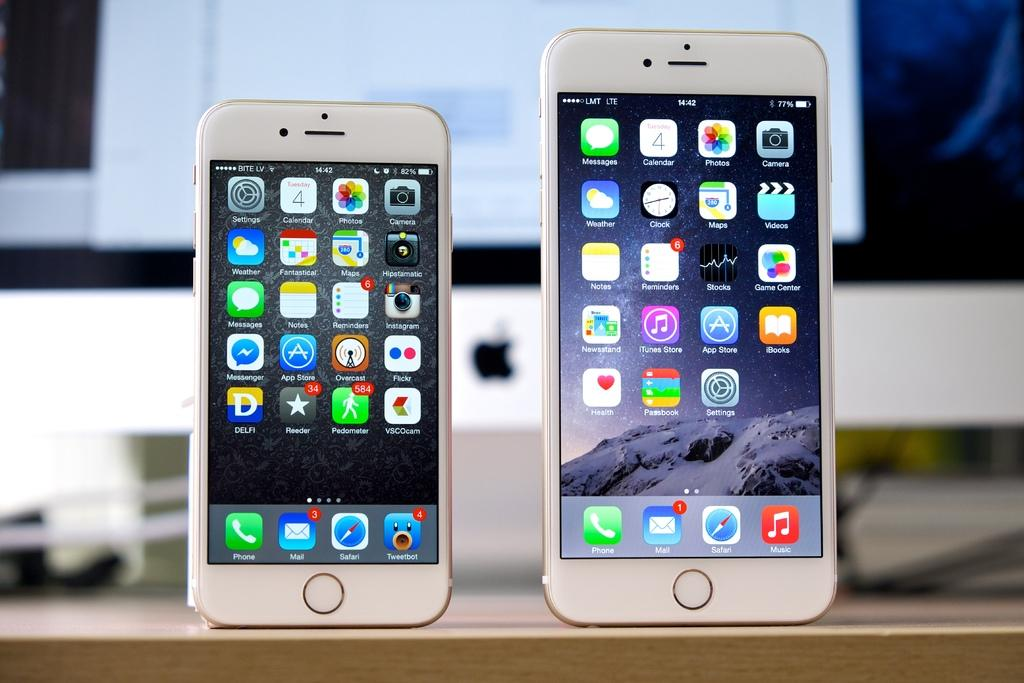What electronic devices are on the table in the image? There are cell phones on the table in the image. What can be seen on the cell phone screens? There are icons and text on the cell phone screens. What is located at the back of the image? There is a computer at the back of the image. What else is visible in the image besides the electronic devices? There are wires visible in the image. How many hydrants are visible in the image? There are no hydrants present in the image. What type of beam is supporting the computer in the image? There is no beam visible in the image, and the computer is not shown to be supported by any beam. 